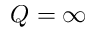Convert formula to latex. <formula><loc_0><loc_0><loc_500><loc_500>Q = \infty</formula> 